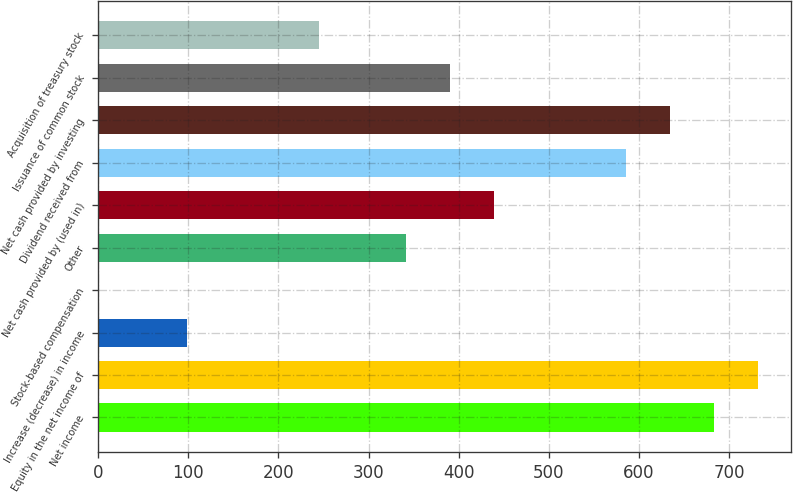Convert chart. <chart><loc_0><loc_0><loc_500><loc_500><bar_chart><fcel>Net income<fcel>Equity in the net income of<fcel>Increase (decrease) in income<fcel>Stock-based compensation<fcel>Other<fcel>Net cash provided by (used in)<fcel>Dividend received from<fcel>Net cash provided by investing<fcel>Issuance of common stock<fcel>Acquisition of treasury stock<nl><fcel>683.08<fcel>731.8<fcel>98.44<fcel>1<fcel>342.04<fcel>439.48<fcel>585.64<fcel>634.36<fcel>390.76<fcel>244.6<nl></chart> 